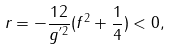Convert formula to latex. <formula><loc_0><loc_0><loc_500><loc_500>r = - \frac { 1 2 } { g ^ { ^ { \prime } 2 } } ( f ^ { 2 } + \frac { 1 } { 4 } ) < 0 ,</formula> 